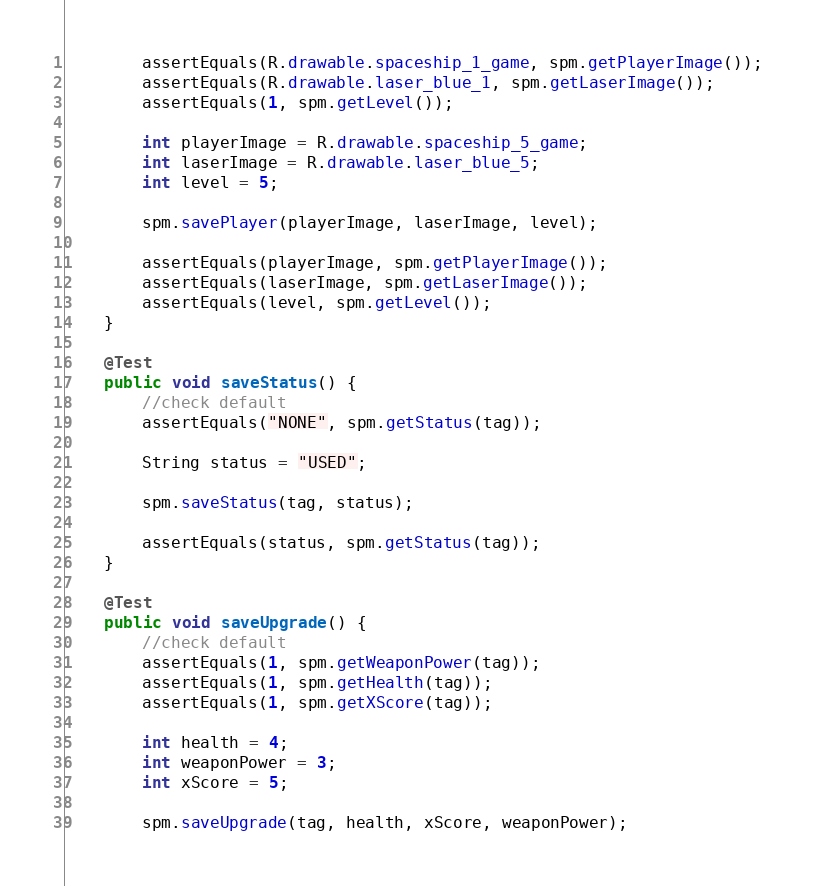Convert code to text. <code><loc_0><loc_0><loc_500><loc_500><_Java_>        assertEquals(R.drawable.spaceship_1_game, spm.getPlayerImage());
        assertEquals(R.drawable.laser_blue_1, spm.getLaserImage());
        assertEquals(1, spm.getLevel());

        int playerImage = R.drawable.spaceship_5_game;
        int laserImage = R.drawable.laser_blue_5;
        int level = 5;

        spm.savePlayer(playerImage, laserImage, level);

        assertEquals(playerImage, spm.getPlayerImage());
        assertEquals(laserImage, spm.getLaserImage());
        assertEquals(level, spm.getLevel());
    }

    @Test
    public void saveStatus() {
        //check default
        assertEquals("NONE", spm.getStatus(tag));

        String status = "USED";

        spm.saveStatus(tag, status);

        assertEquals(status, spm.getStatus(tag));
    }

    @Test
    public void saveUpgrade() {
        //check default
        assertEquals(1, spm.getWeaponPower(tag));
        assertEquals(1, spm.getHealth(tag));
        assertEquals(1, spm.getXScore(tag));

        int health = 4;
        int weaponPower = 3;
        int xScore = 5;

        spm.saveUpgrade(tag, health, xScore, weaponPower);
</code> 